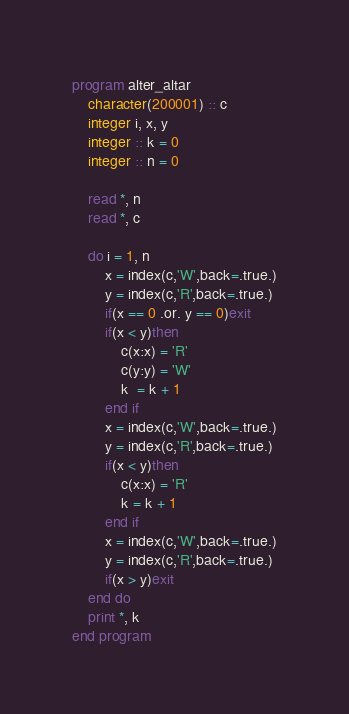<code> <loc_0><loc_0><loc_500><loc_500><_FORTRAN_>program alter_altar
    character(200001) :: c
    integer i, x, y
    integer :: k = 0
    integer :: n = 0

    read *, n
    read *, c

    do i = 1, n
        x = index(c,'W',back=.true.)
        y = index(c,'R',back=.true.)
        if(x == 0 .or. y == 0)exit
        if(x < y)then
            c(x:x) = 'R'
            c(y:y) = 'W'
            k  = k + 1
        end if
        x = index(c,'W',back=.true.)
        y = index(c,'R',back=.true.)
        if(x < y)then
            c(x:x) = 'R'
            k = k + 1
        end if
        x = index(c,'W',back=.true.)
        y = index(c,'R',back=.true.)
        if(x > y)exit
    end do
    print *, k
end program</code> 